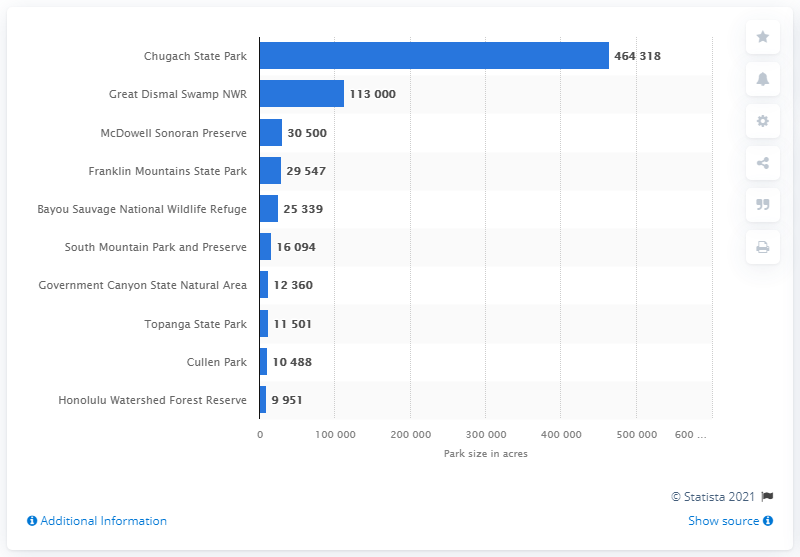Mention a couple of crucial points in this snapshot. Chugach State Park is the largest city park in the United States. 